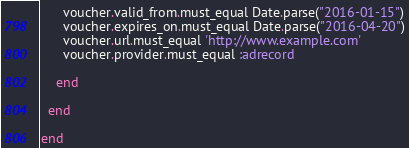<code> <loc_0><loc_0><loc_500><loc_500><_Ruby_>      voucher.valid_from.must_equal Date.parse("2016-01-15")
      voucher.expires_on.must_equal Date.parse("2016-04-20")
      voucher.url.must_equal 'http://www.example.com'
      voucher.provider.must_equal :adrecord

    end

  end

end
</code> 